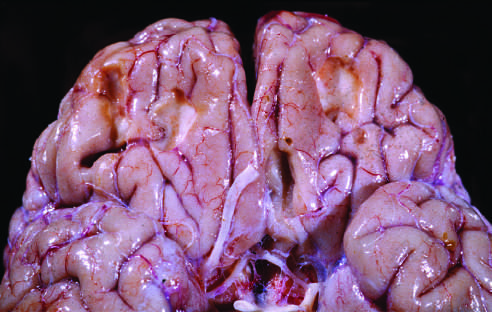what are remote contusions seen as?
Answer the question using a single word or phrase. Discolored yellow areas 